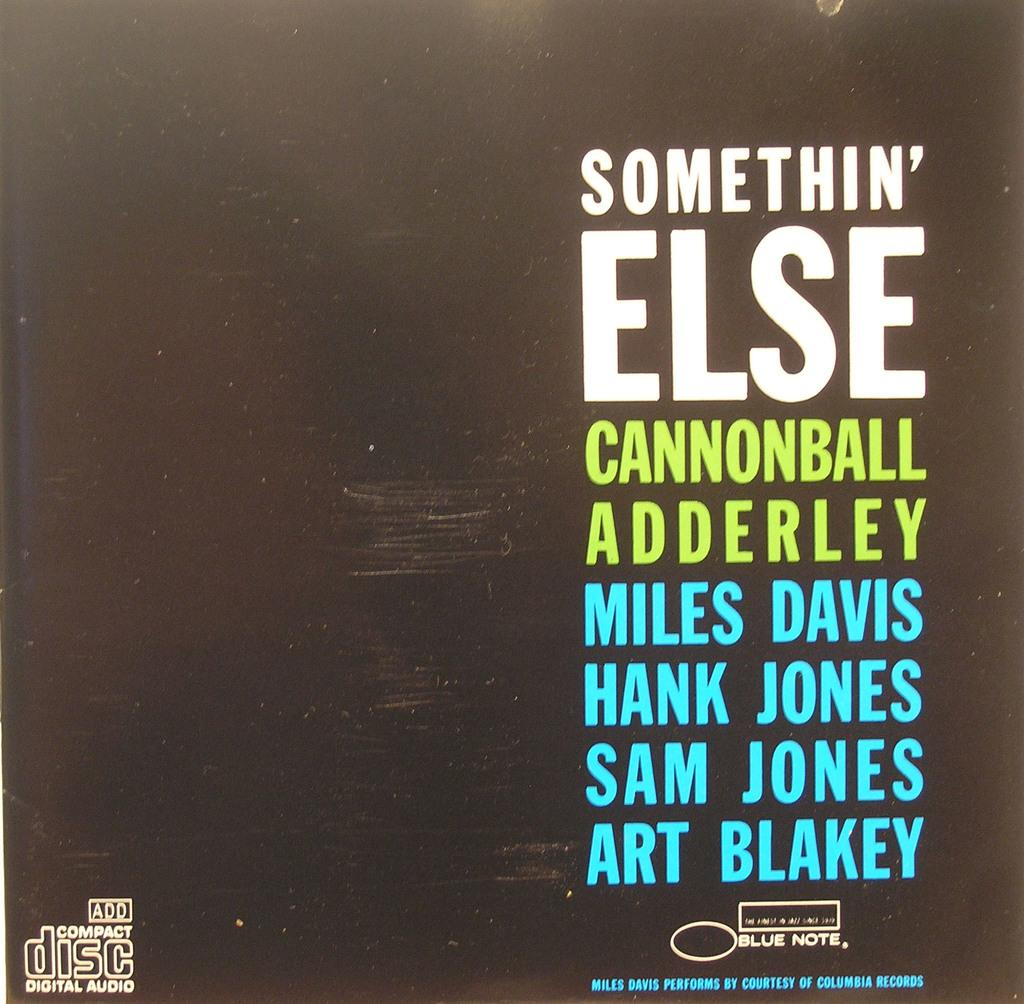<image>
Describe the image concisely. A compact disc compilation features artists like Miles Davis, Hank Jones, and Sam Jones. 